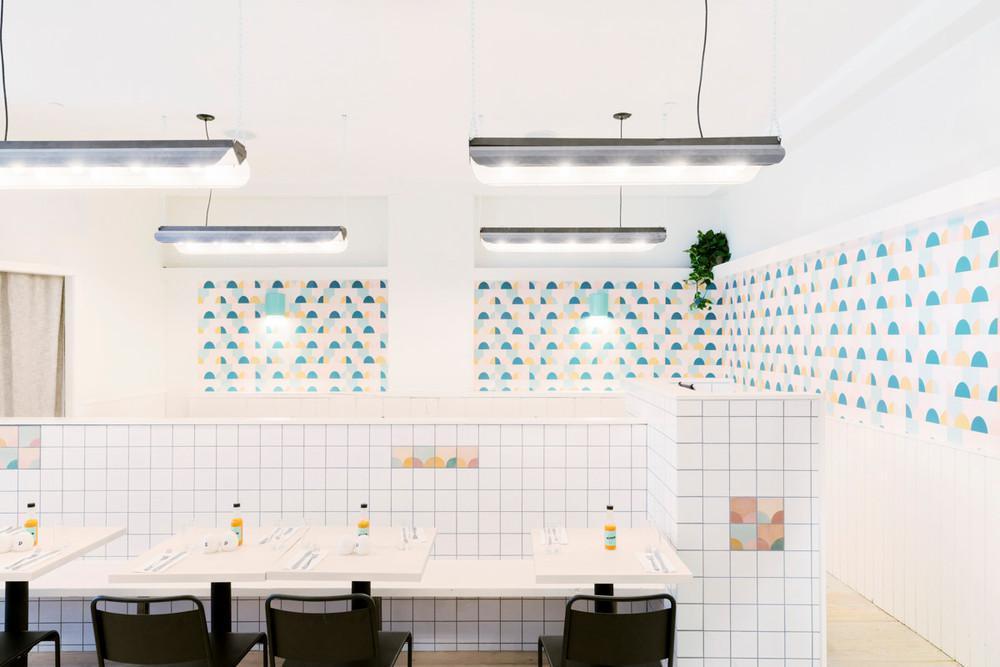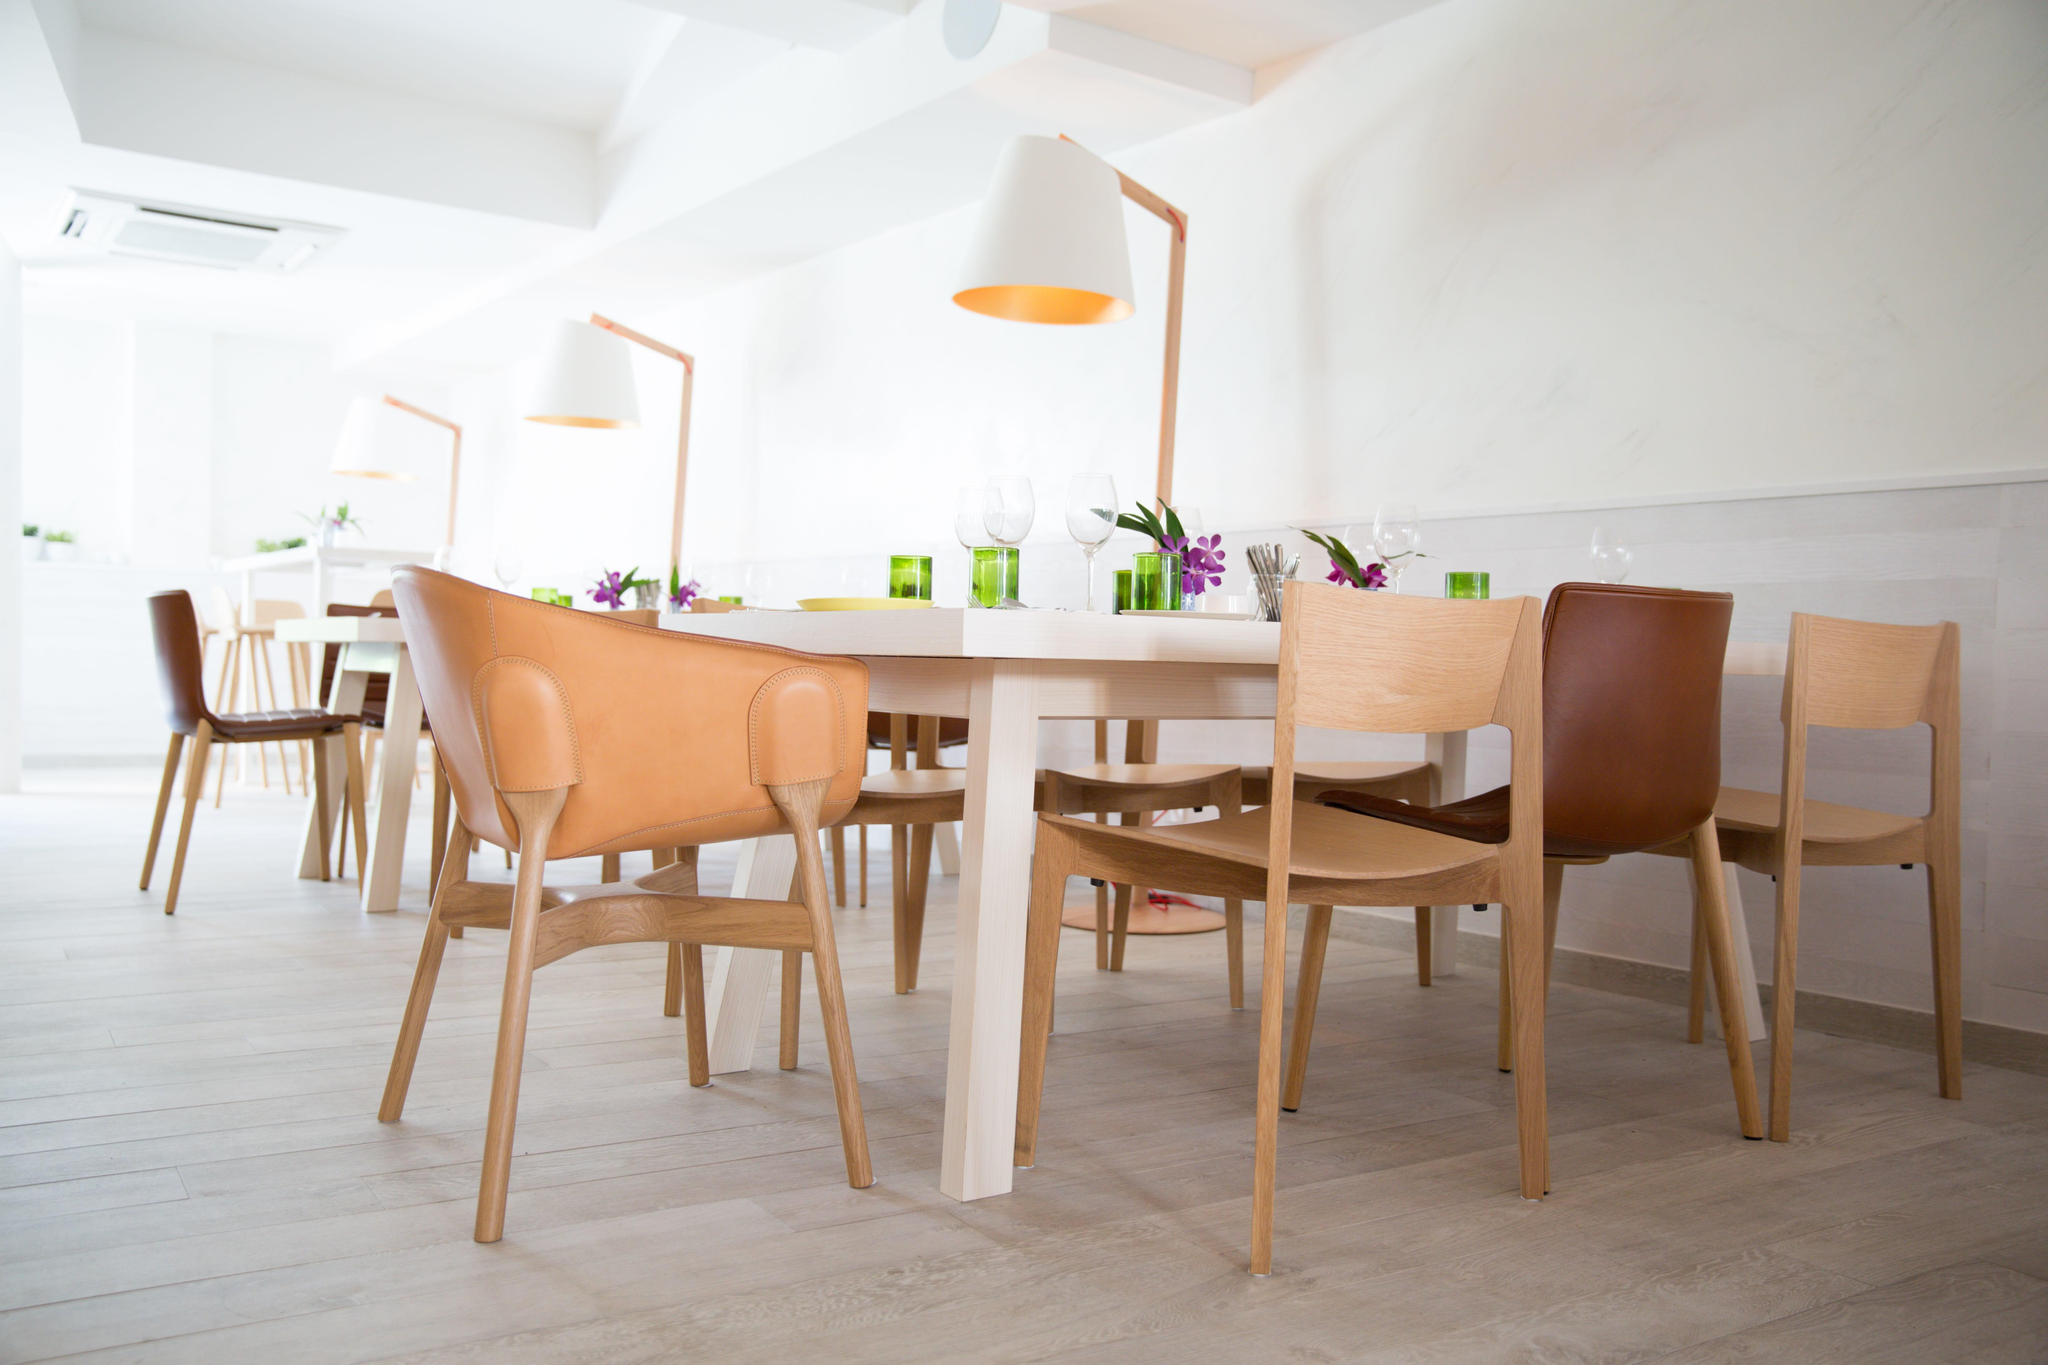The first image is the image on the left, the second image is the image on the right. Evaluate the accuracy of this statement regarding the images: "There are chairs in both images.". Is it true? Answer yes or no. Yes. The first image is the image on the left, the second image is the image on the right. Examine the images to the left and right. Is the description "Each image shows a seating area with lights suspended over it, and one of the images features black chairs in front of small square tables flush with a low wall." accurate? Answer yes or no. Yes. 